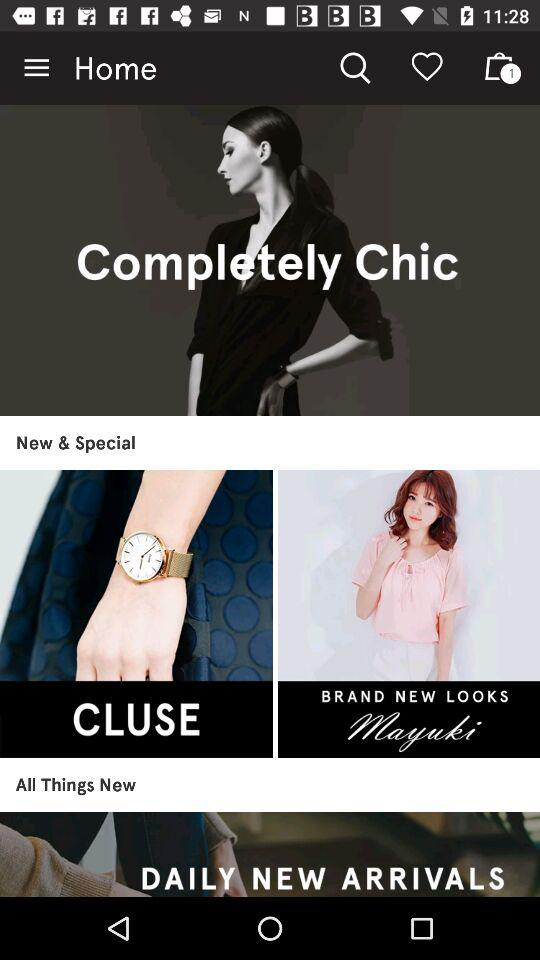What is the number of items in the bag? The number of items is 1. 